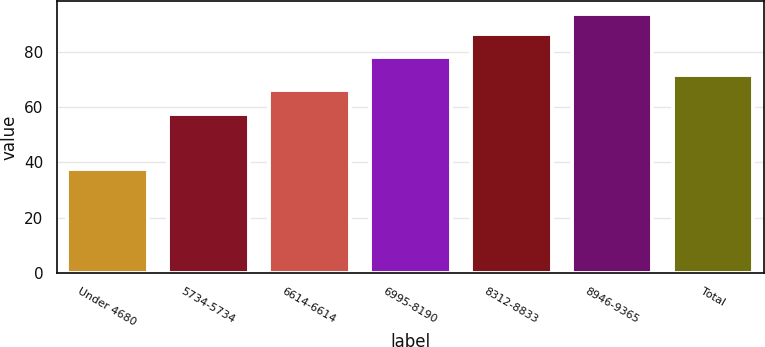<chart> <loc_0><loc_0><loc_500><loc_500><bar_chart><fcel>Under 4680<fcel>5734-5734<fcel>6614-6614<fcel>6995-8190<fcel>8312-8833<fcel>8946-9365<fcel>Total<nl><fcel>37.53<fcel>57.34<fcel>66.14<fcel>77.94<fcel>86.38<fcel>93.57<fcel>71.74<nl></chart> 